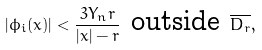Convert formula to latex. <formula><loc_0><loc_0><loc_500><loc_500>| \phi _ { i } ( x ) | < \frac { 3 Y _ { n } r } { | x | - r } \ \text {outside} \ \overline { D _ { r } } ,</formula> 